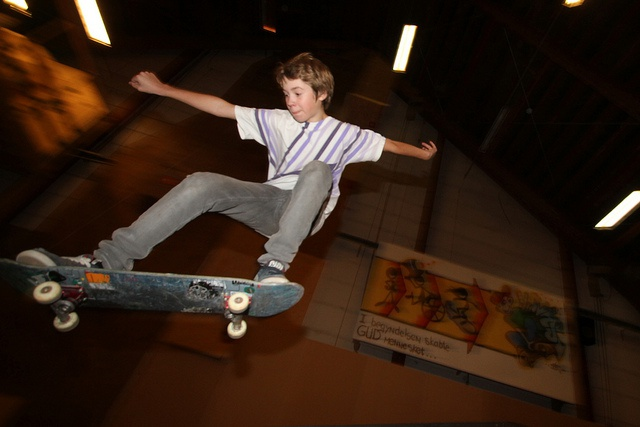Describe the objects in this image and their specific colors. I can see people in black, gray, lightgray, and darkgray tones and skateboard in black, gray, and darkgray tones in this image. 